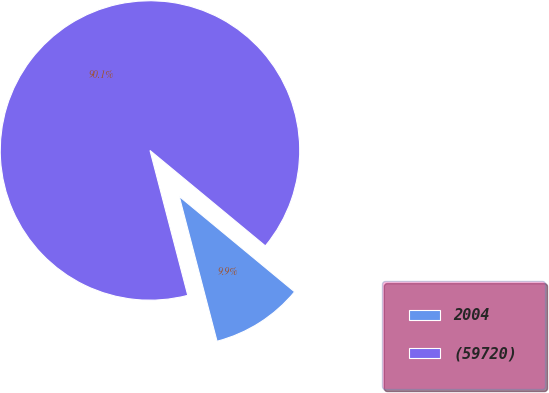<chart> <loc_0><loc_0><loc_500><loc_500><pie_chart><fcel>2004<fcel>(59720)<nl><fcel>9.94%<fcel>90.06%<nl></chart> 